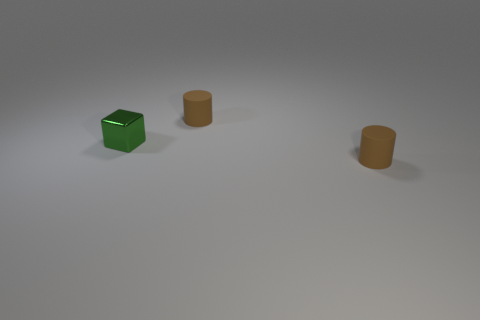Add 3 small brown things. How many objects exist? 6 Subtract all cylinders. How many objects are left? 1 Subtract all large rubber cylinders. Subtract all matte cylinders. How many objects are left? 1 Add 3 small cylinders. How many small cylinders are left? 5 Add 2 small brown things. How many small brown things exist? 4 Subtract 0 gray cubes. How many objects are left? 3 